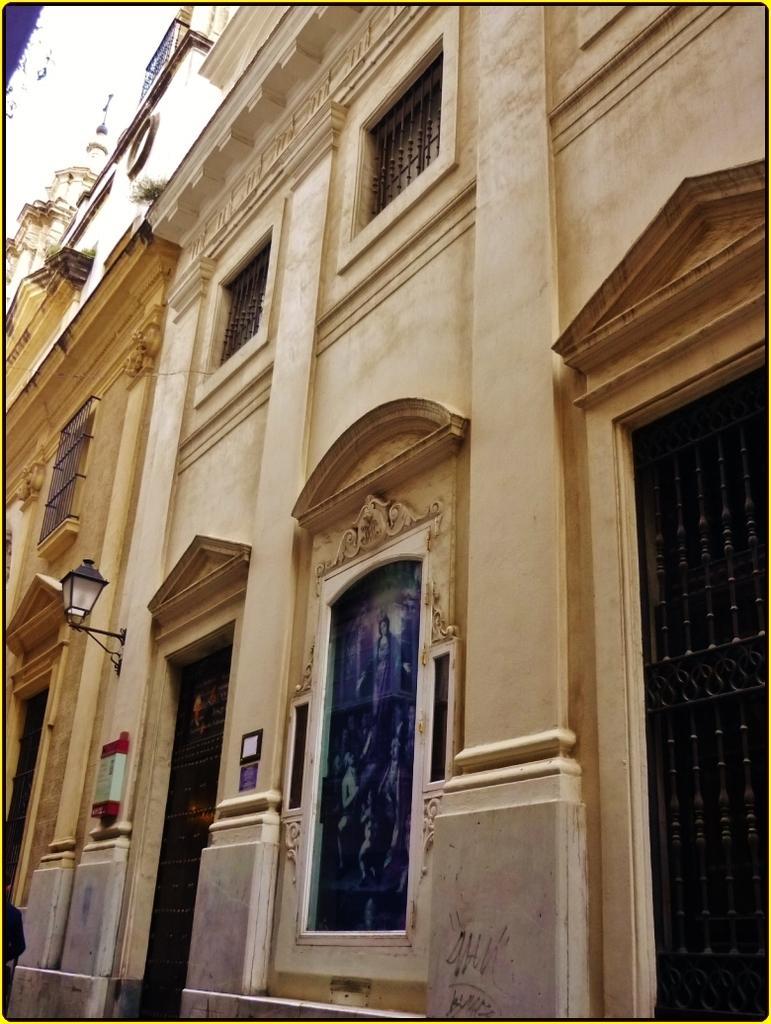Describe this image in one or two sentences. In this image there is a big building with glass windows and light on the wall. 